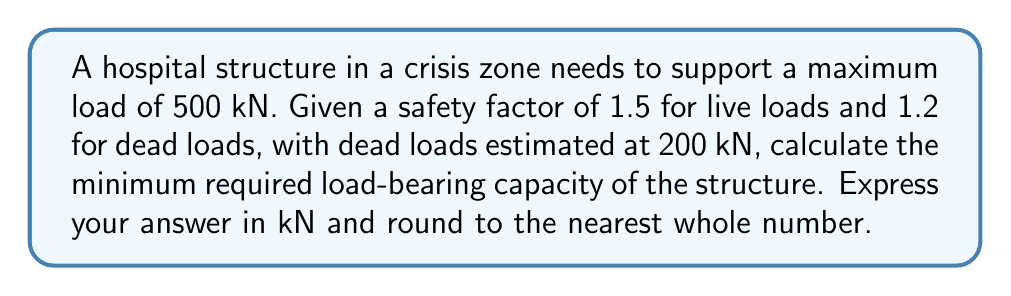Could you help me with this problem? Let's approach this step-by-step:

1) First, we need to understand the given information:
   - Maximum load = 500 kN
   - Safety factor for live loads = 1.5
   - Safety factor for dead loads = 1.2
   - Estimated dead loads = 200 kN

2) Calculate the live load:
   Live load = Maximum load - Dead load
   $$ L = 500 \text{ kN} - 200 \text{ kN} = 300 \text{ kN} $$

3) Apply safety factors to both loads:
   Factored dead load = Dead load × Safety factor for dead loads
   $$ D_f = 200 \text{ kN} \times 1.2 = 240 \text{ kN} $$
   
   Factored live load = Live load × Safety factor for live loads
   $$ L_f = 300 \text{ kN} \times 1.5 = 450 \text{ kN} $$

4) Calculate the total required load-bearing capacity:
   Total capacity = Factored dead load + Factored live load
   $$ C = D_f + L_f = 240 \text{ kN} + 450 \text{ kN} = 690 \text{ kN} $$

5) Round to the nearest whole number:
   $$ C \approx 690 \text{ kN} $$

Therefore, the minimum required load-bearing capacity of the structure is 690 kN.
Answer: 690 kN 